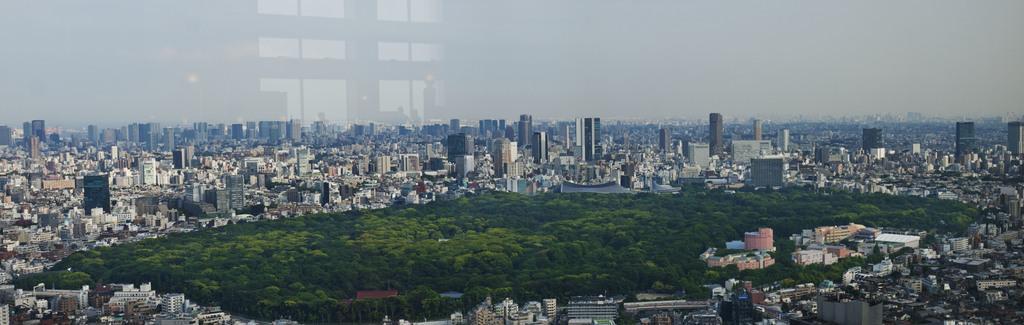Could you give a brief overview of what you see in this image? This is a picture of a city , where there are buildings, trees, and in the background there is sky. 